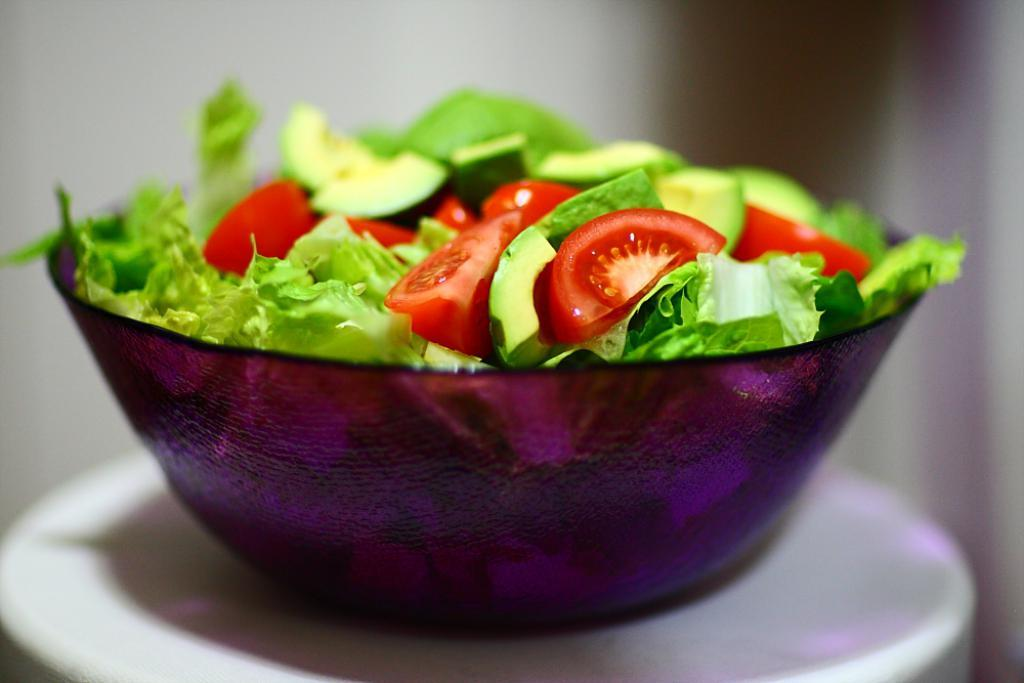What is in the serving bowl that is visible in the image? The serving bowl contains salad. Where is the serving bowl located in the image? The serving bowl is placed on a serving plate. What type of dress is the salad wearing in the image? There is no dress present in the image, as the salad is in a serving bowl and not a person. 